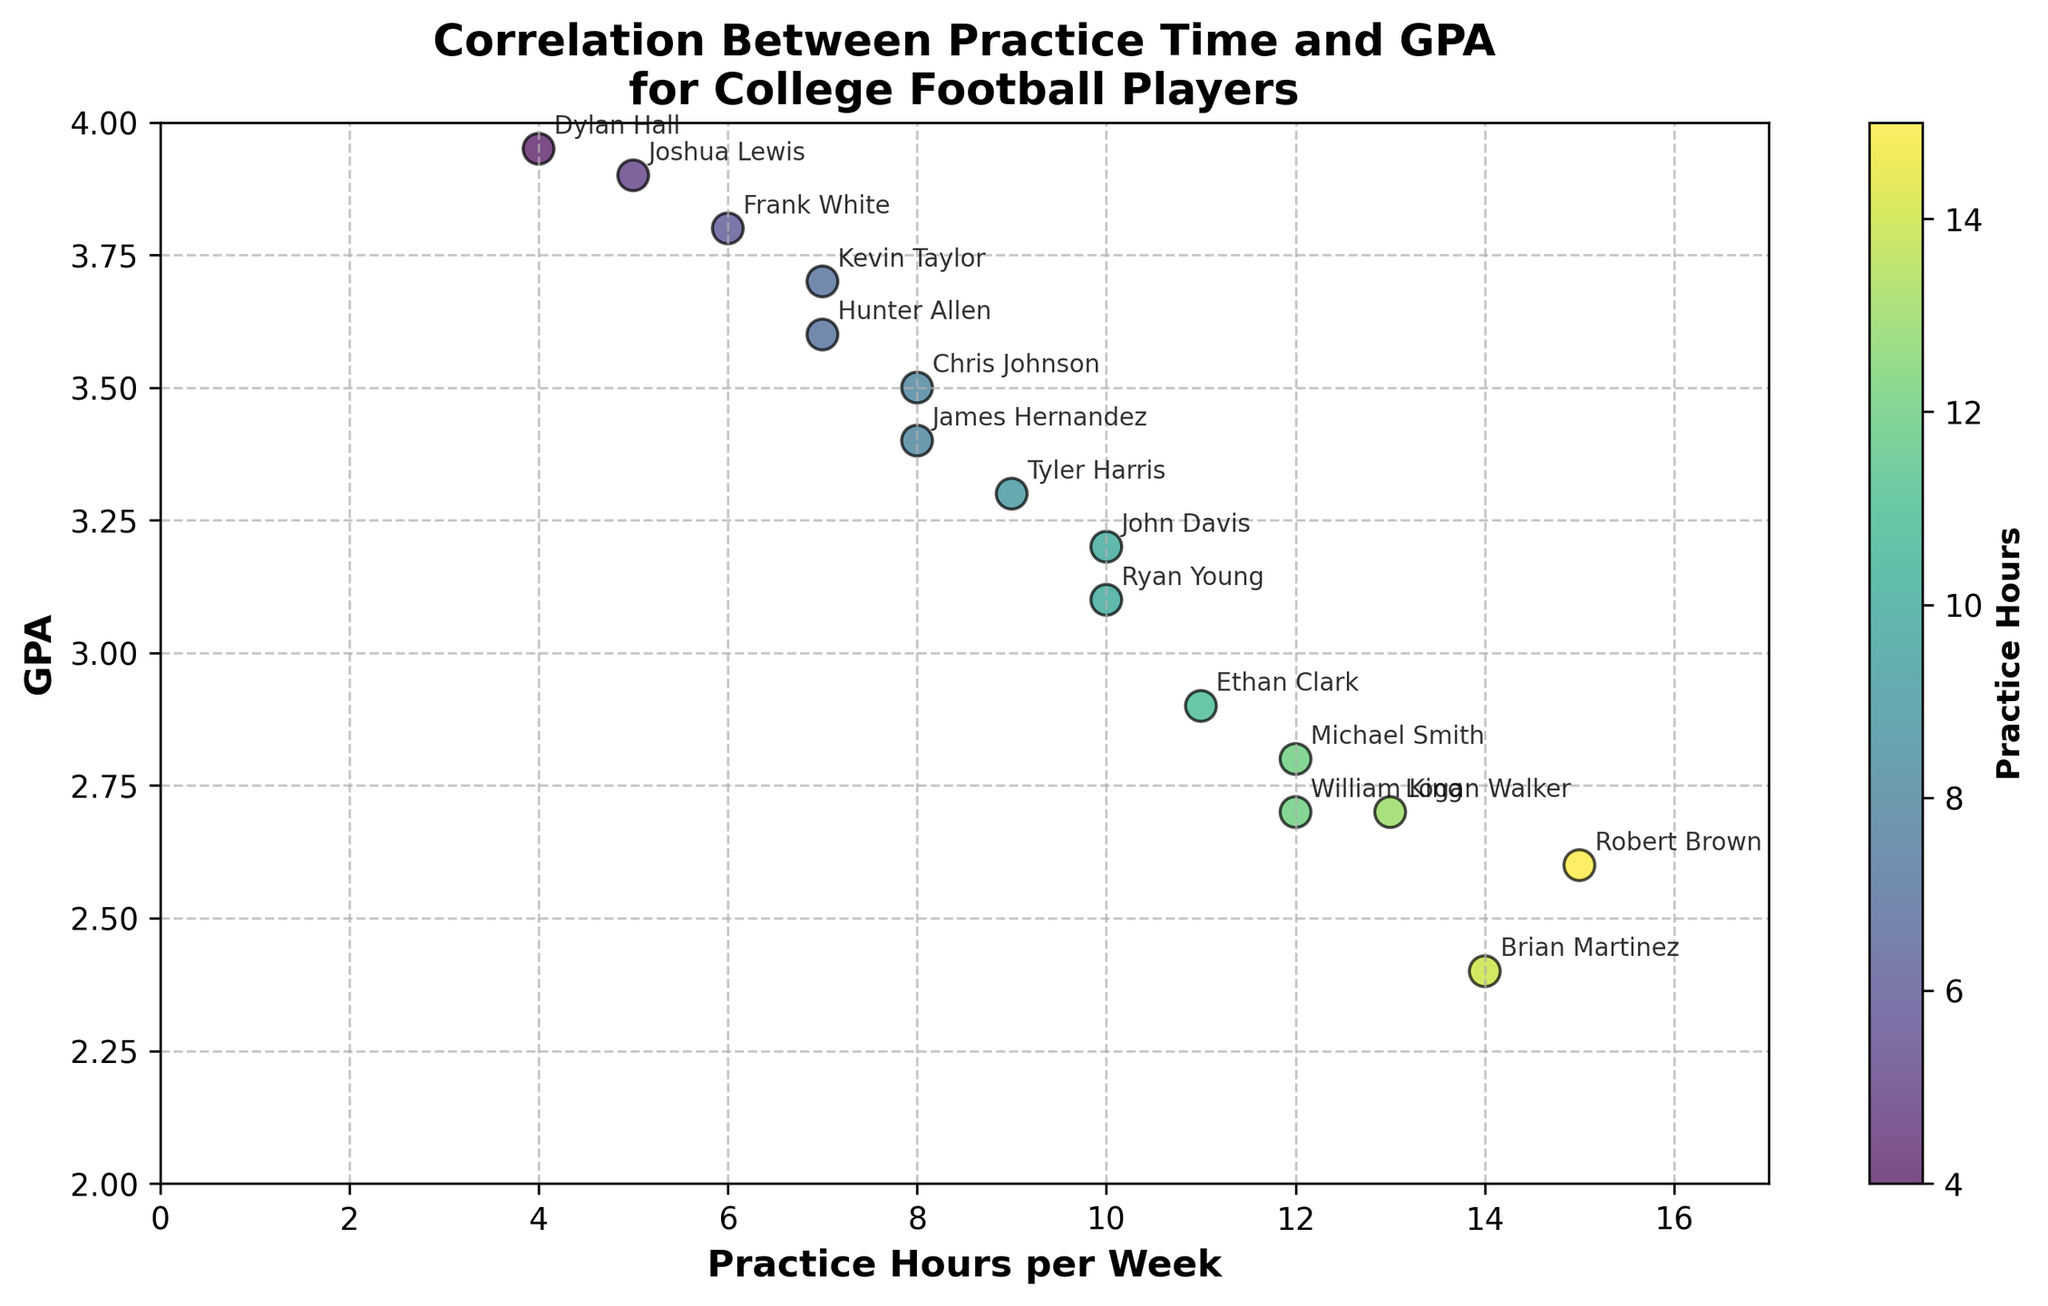How many players practiced for 10 hours per week? Locate the practice_hours axis and count the instances where the value is 10.
Answer: 2 What is the GPA of the player who practiced 4 hours per week? Identify the player on the scatter plot whose practice hours are 4 and read the corresponding GPA on the vertical axis.
Answer: 3.95 Who spent the most and least hours practicing per week, and what were their GPAs? Find the maximum and minimum values on the practice_hours axis, then refer to the corresponding points and their GPAs on the vertical axis.
Answer: Robert Brown (15, 2.6) and Dylan Hall (4, 3.95) What is the title of the chart? Read the title text located above the scatter plot.
Answer: Correlation Between Practice Time and GPA for College Football Players What is the overall trend between practice hours and GPA? Observe the scatter plot to determine if there is a positive or negative correlation by looking at how GPA varies with practice hours.
Answer: Negative correlation Which player has the highest GPA, and how many hours does he practice per week? Locate the highest point on the y-axis (GPA) and read the corresponding practice hours from the x-axis, then identify the player from the annotation.
Answer: Dylan Hall (4 hours per week) Compare the GPAs of Kevin Taylor and Michael Smith. Who has a higher GPA? Locate the points on the scatter plot for Kevin Taylor's and Michael Smith's practice hours and compare their corresponding GPAs.
Answer: Kevin Taylor Calculate the average practice hours per week for all players. Sum all practice hours and divide by the number of players: (10+12+8+15+7+14+6+9+11+5+13+4+7+10+8+12)/16 = 9.4375
Answer: 9.4375 What's the median GPA of all players? Arrange all GPA values in ascending order and identify the middle value(s): 2.4, 2.6, 2.7, 2.7, 2.8, 2.9, 3.1, 3.2, 3.3, 3.4, 3.5, 3.6, 3.7, 3.8, 3.9, 3.95. The median is the average of the 8th and 9th values: (3.2+3.3)/2 = 3.25
Answer: 3.25 What is the color of the data points, and what does it represent? Look at the color scheme of the scatter plot and refer to the color bar on the right side of the graph to understand what it represents.
Answer: Varying shades of green represent practice hours 